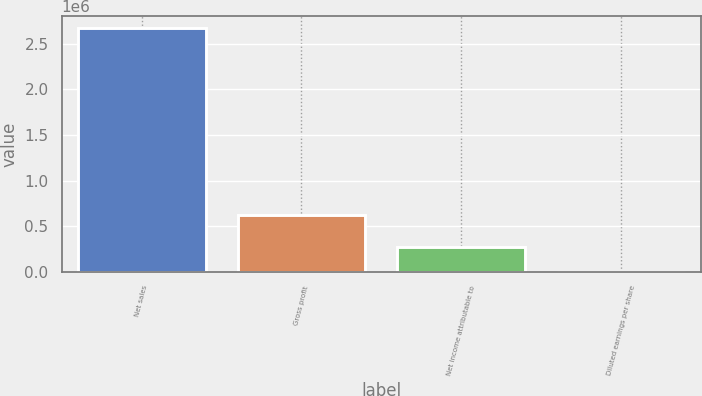Convert chart. <chart><loc_0><loc_0><loc_500><loc_500><bar_chart><fcel>Net sales<fcel>Gross profit<fcel>Net income attributable to<fcel>Diluted earnings per share<nl><fcel>2.6708e+06<fcel>626320<fcel>267082<fcel>1.78<nl></chart> 